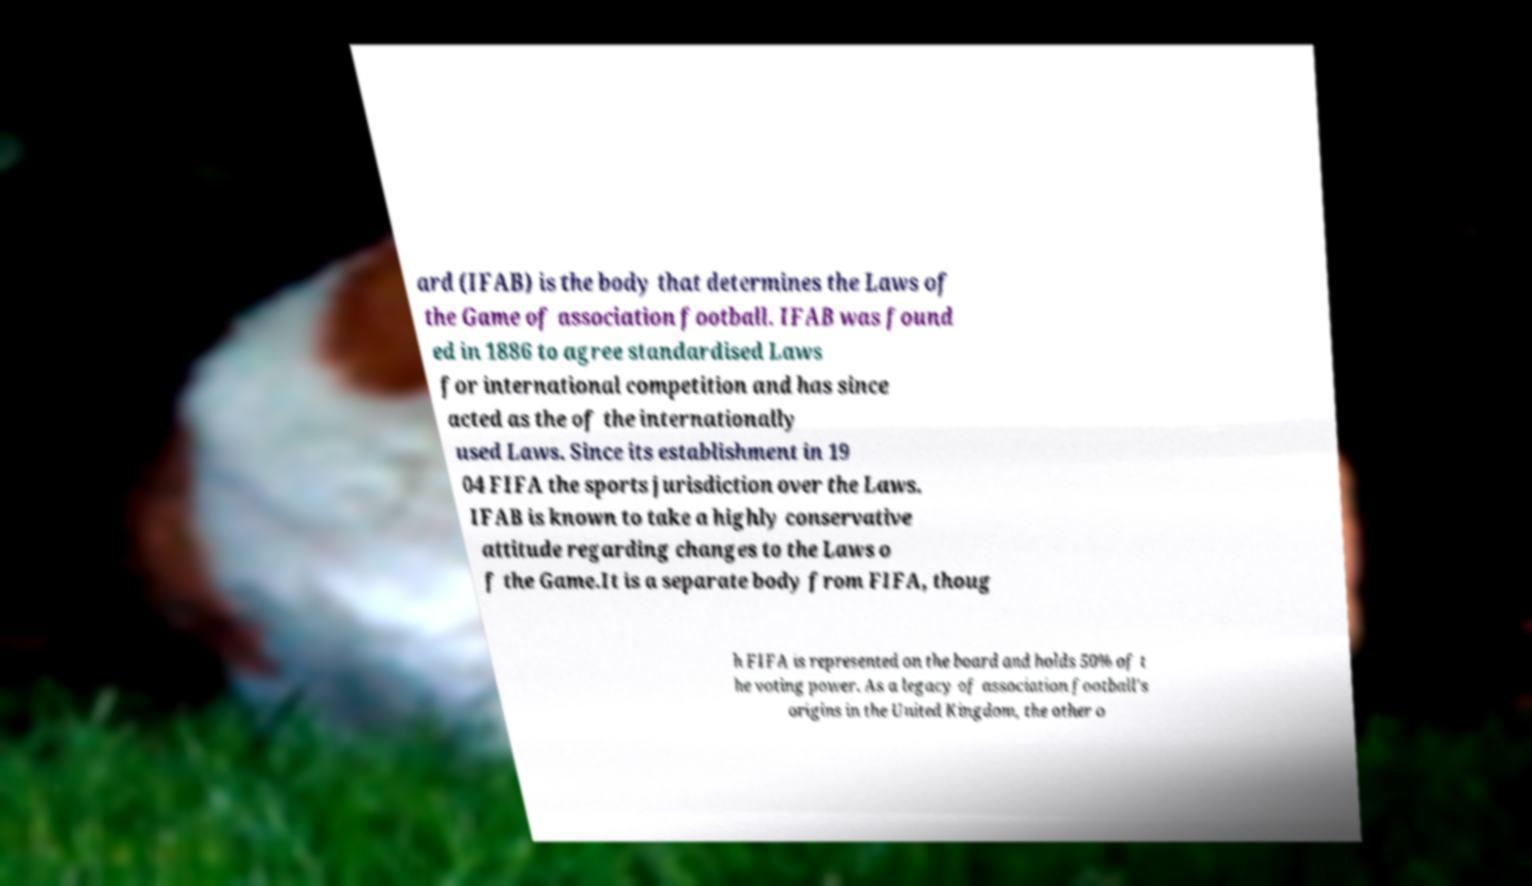Could you assist in decoding the text presented in this image and type it out clearly? ard (IFAB) is the body that determines the Laws of the Game of association football. IFAB was found ed in 1886 to agree standardised Laws for international competition and has since acted as the of the internationally used Laws. Since its establishment in 19 04 FIFA the sports jurisdiction over the Laws. IFAB is known to take a highly conservative attitude regarding changes to the Laws o f the Game.It is a separate body from FIFA, thoug h FIFA is represented on the board and holds 50% of t he voting power. As a legacy of association football's origins in the United Kingdom, the other o 